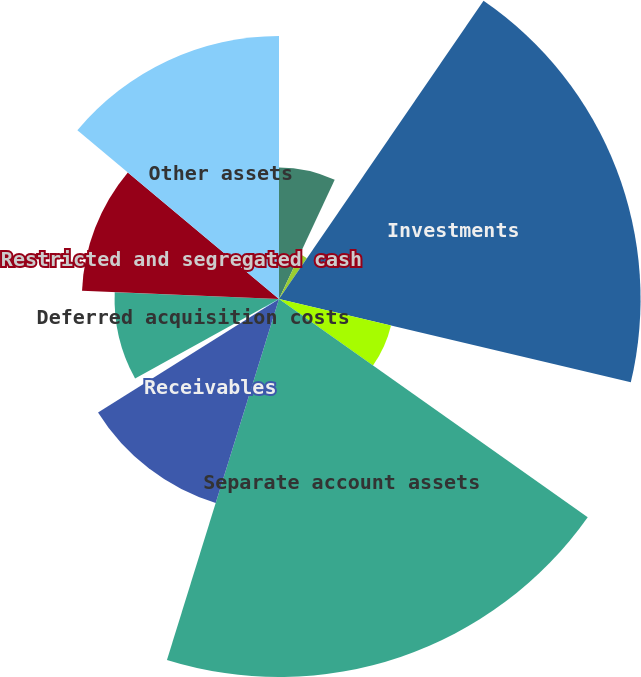Convert chart. <chart><loc_0><loc_0><loc_500><loc_500><pie_chart><fcel>Cash and cash equivalents<fcel>Cash of consolidated<fcel>Investments<fcel>Investments of consolidated<fcel>Separate account assets<fcel>Receivables<fcel>Receivables of consolidated<fcel>Deferred acquisition costs<fcel>Restricted and segregated cash<fcel>Other assets<nl><fcel>6.96%<fcel>2.61%<fcel>19.13%<fcel>6.09%<fcel>20.0%<fcel>11.3%<fcel>0.87%<fcel>8.7%<fcel>10.43%<fcel>13.91%<nl></chart> 